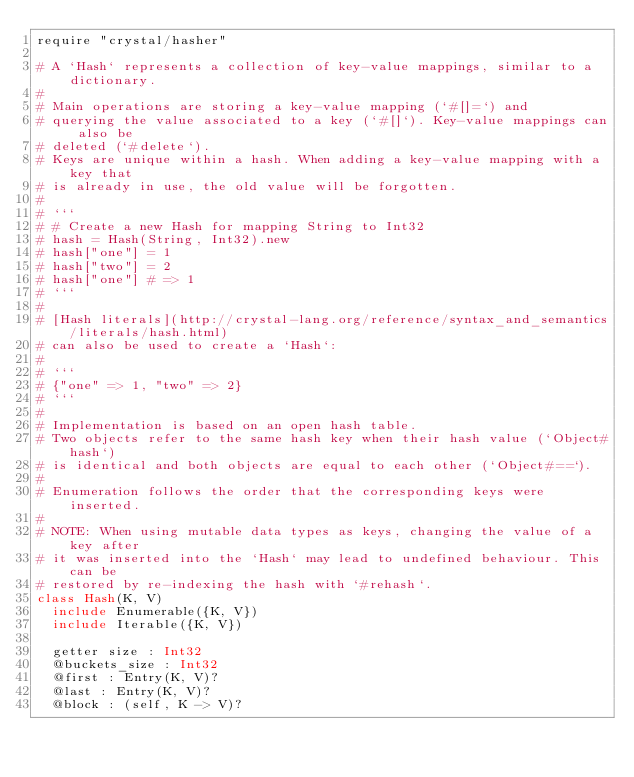Convert code to text. <code><loc_0><loc_0><loc_500><loc_500><_Crystal_>require "crystal/hasher"

# A `Hash` represents a collection of key-value mappings, similar to a dictionary.
#
# Main operations are storing a key-value mapping (`#[]=`) and
# querying the value associated to a key (`#[]`). Key-value mappings can also be
# deleted (`#delete`).
# Keys are unique within a hash. When adding a key-value mapping with a key that
# is already in use, the old value will be forgotten.
#
# ```
# # Create a new Hash for mapping String to Int32
# hash = Hash(String, Int32).new
# hash["one"] = 1
# hash["two"] = 2
# hash["one"] # => 1
# ```
#
# [Hash literals](http://crystal-lang.org/reference/syntax_and_semantics/literals/hash.html)
# can also be used to create a `Hash`:
#
# ```
# {"one" => 1, "two" => 2}
# ```
#
# Implementation is based on an open hash table.
# Two objects refer to the same hash key when their hash value (`Object#hash`)
# is identical and both objects are equal to each other (`Object#==`).
#
# Enumeration follows the order that the corresponding keys were inserted.
#
# NOTE: When using mutable data types as keys, changing the value of a key after
# it was inserted into the `Hash` may lead to undefined behaviour. This can be
# restored by re-indexing the hash with `#rehash`.
class Hash(K, V)
  include Enumerable({K, V})
  include Iterable({K, V})

  getter size : Int32
  @buckets_size : Int32
  @first : Entry(K, V)?
  @last : Entry(K, V)?
  @block : (self, K -> V)?
</code> 